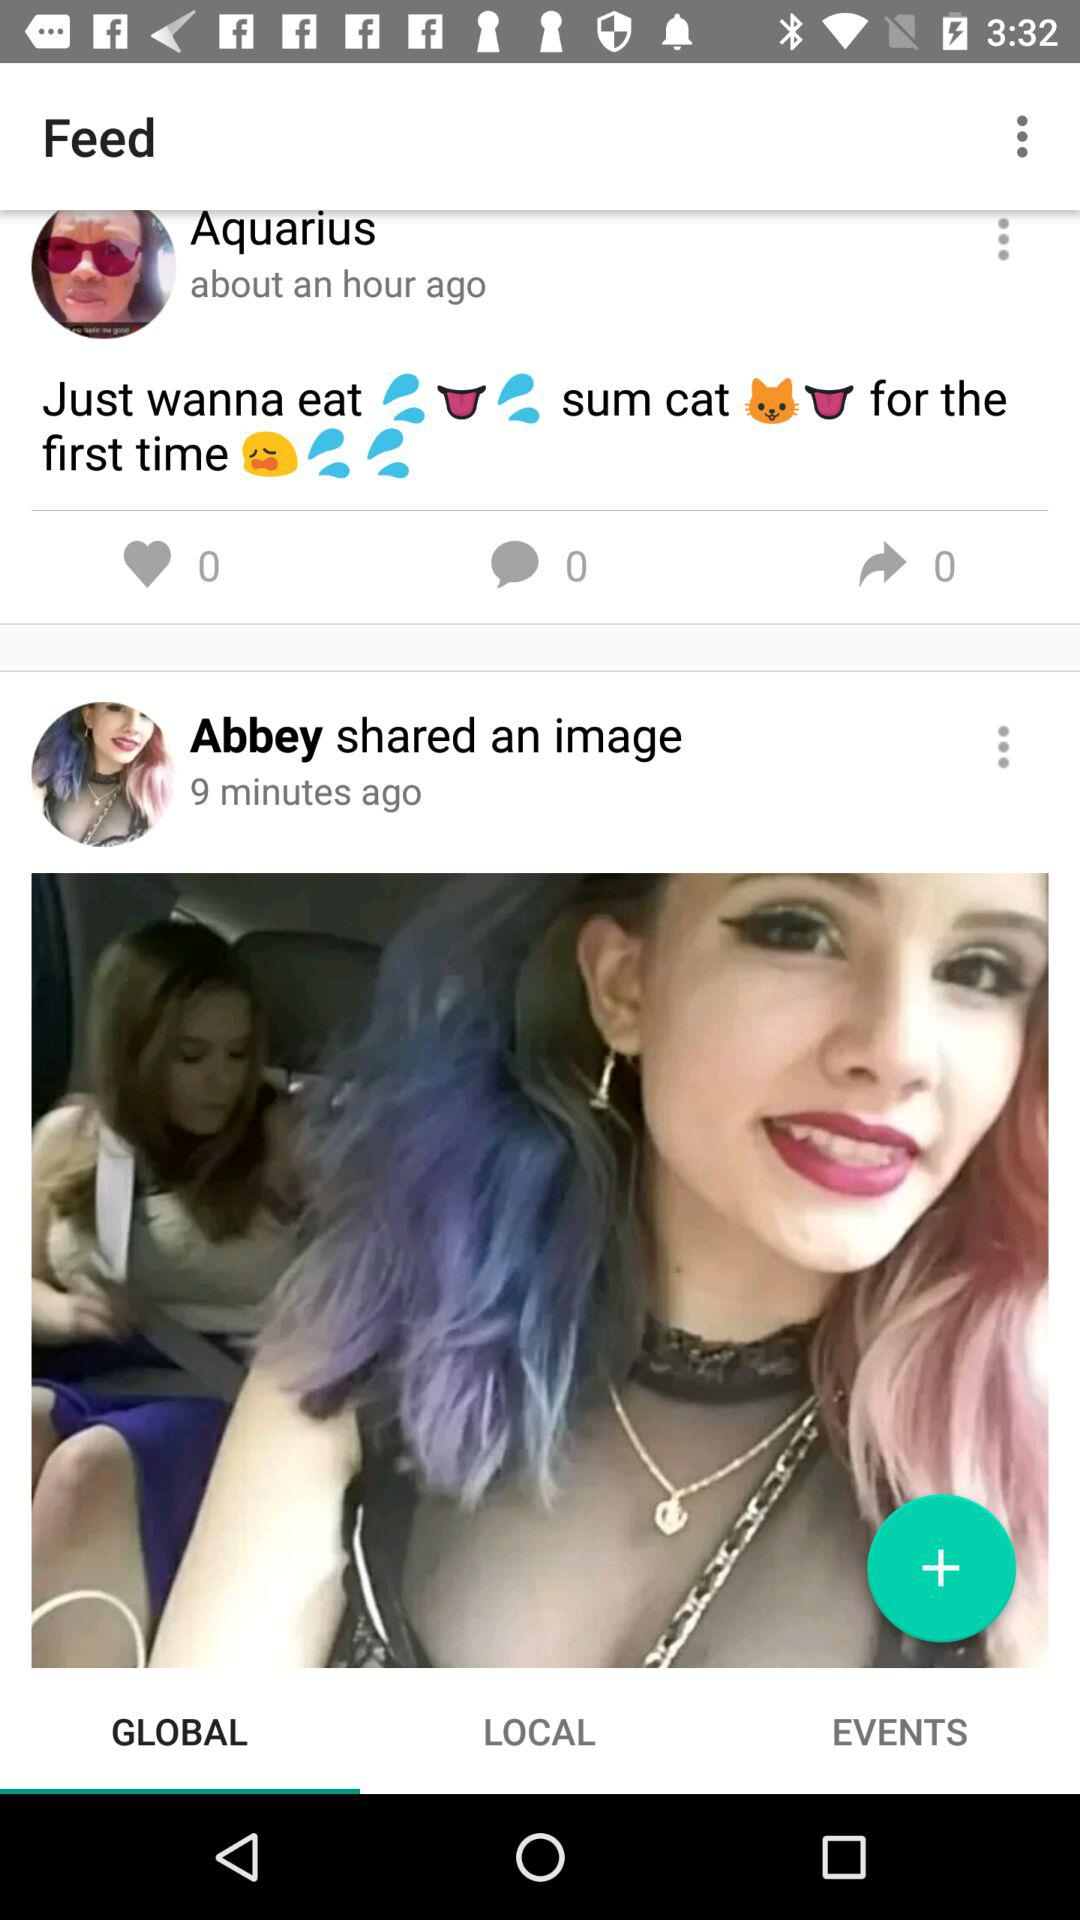What tab is selected? The selected tab is "GLOBAL". 